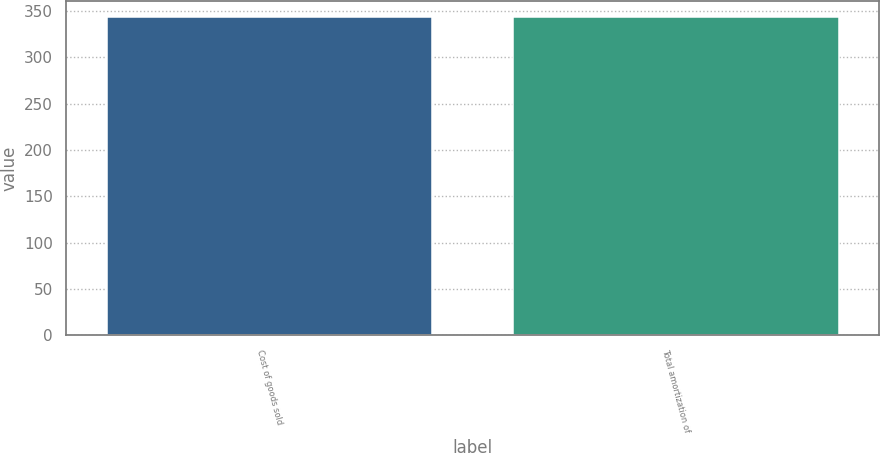<chart> <loc_0><loc_0><loc_500><loc_500><bar_chart><fcel>Cost of goods sold<fcel>Total amortization of<nl><fcel>344<fcel>344.1<nl></chart> 